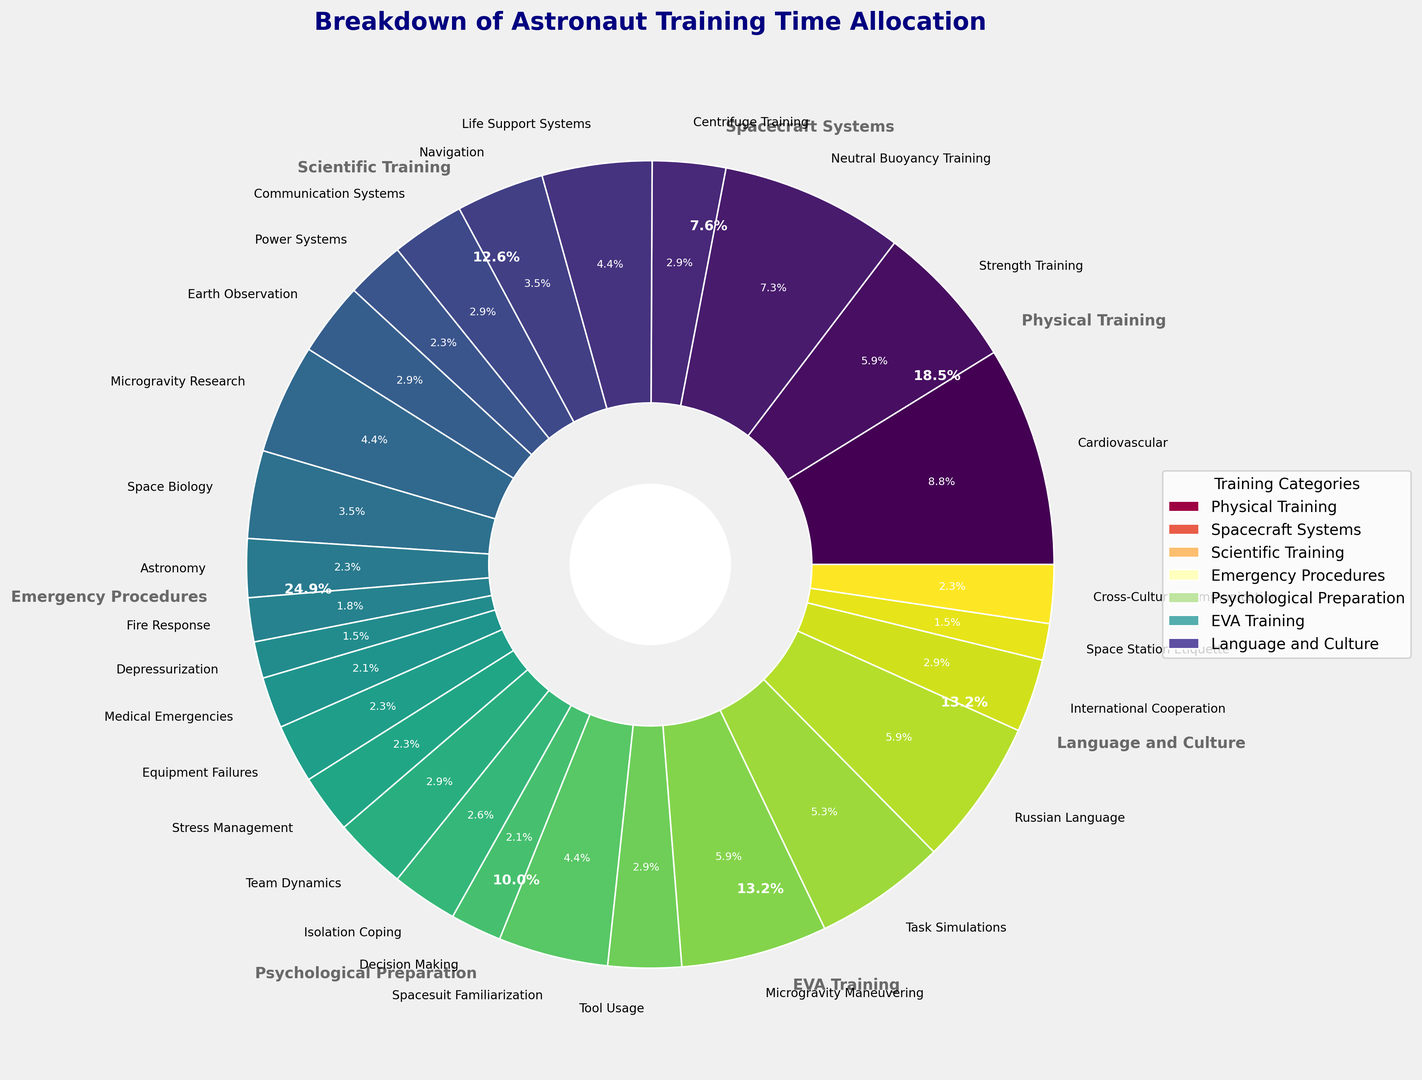What percentage of total training time is allocated to "Physical Training"? To determine the percentage of total training time allocated to "Physical Training," sum the hours of all its subcategories (Cardiovascular: 300, Strength Training: 200, Neutral Buoyancy Training: 250, Centrifuge Training: 100) which equals 850 hours. Then, sum the hours of all categories to get the total training time. The total training time is 3000 hours. The percentage for "Physical Training" is (850/3000) * 100%.
Answer: 28.3% Which specific subcategory requires the most hours of training? Locate the subcategory with the largest slice in the inner pie chart. "Cardiovascular" under "Physical Training" has the most hours (300).
Answer: Cardiovascular What's the total training time allocated to "EVA Training" and "Scientific Training" combined? Calculate the sum of hours for all subcategories under "EVA Training" (Spacesuit Familiarization: 150, Tool Usage: 100, Microgravity Maneuvering: 200, Task Simulations: 180) which equals 630 hours. Similarly, sum the hours for "Scientific Training" subcategories (Earth Observation: 100, Microgravity Research: 150, Space Biology: 120, Astronomy: 80) which equals 450 hours. Add these two sums, 630 + 450 = 1080 hours.
Answer: 1080 hours Is more training time allocated to "Psychological Preparation" or "Language and Culture"? Compare the total hours for "Psychological Preparation" (Stress Management: 80, Team Dynamics: 100, Isolation Coping: 90, Decision Making: 70) which equals 340 hours, and "Language and Culture" (Russian Language: 200, International Cooperation: 100, Space Station Etiquette: 50, Cross-Cultural Communication: 80) which equals 430 hours.
Answer: Language and Culture Which category has the smallest share of the training time allocation? Find the smallest slice in the outer pie chart. "Emergency Procedures" with 260 hours, which is the smallest share of the total training time.
Answer: Emergency Procedures What is the average training time per subcategory in "Spacecraft Systems"? To find the average training time per subcategory in "Spacecraft Systems" category, sum the subcategory hours (Life Support Systems: 150, Navigation: 120, Communication Systems: 100, Power Systems: 80) to get 450 hours. Then divide by the number of subcategories (4). The average is 450/4.
Answer: 112.5 hours 